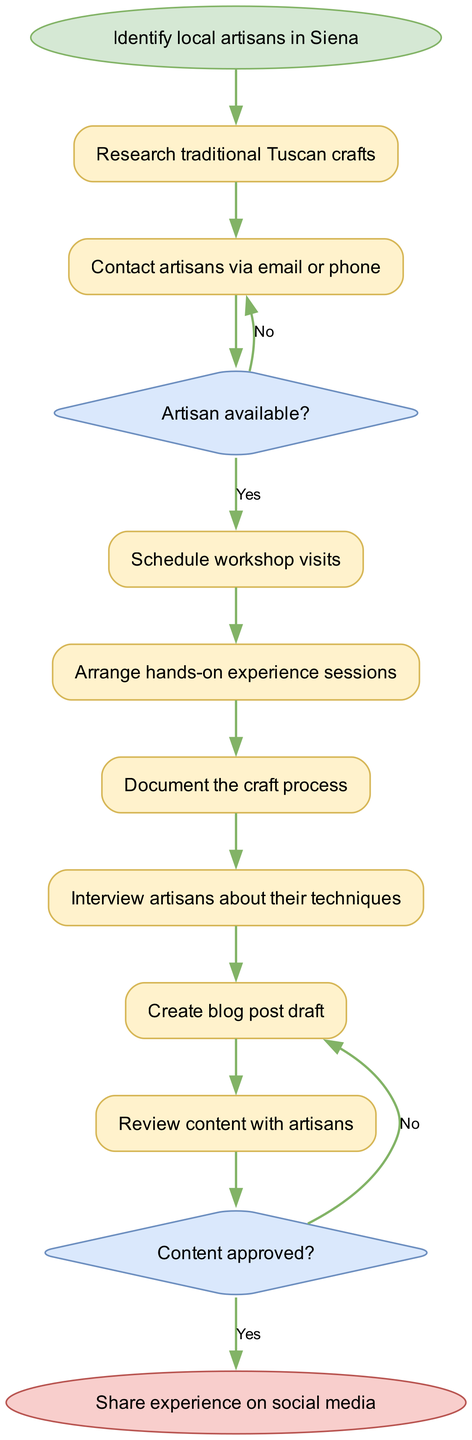What is the starting point of the flow? The starting point of the flow is indicated by the "start" node, which is "Identify local artisans in Siena". This node represents the initial action to take in the process.
Answer: Identify local artisans in Siena How many nodes are in the diagram? The diagram contains a total of 8 nodes, including the start and end nodes, as well as the 6 process nodes that detail the actions taken.
Answer: 8 What is the first process node after the start node? The first process node that follows the start node is "Research traditional Tuscan crafts". This node outlines the first step in the workflow.
Answer: Research traditional Tuscan crafts What is the outcome when an artisan is available? If the artisan is available, the process moves to the "Schedule workshop visits" node, as indicated in the decision that follows the artisan availability check.
Answer: Schedule workshop visits What happens if the content is not approved? If the content is not approved, it leads back to the "Revise content" node for further editing before possibly re-approving. This is indicated in the last decision of the chart.
Answer: Revise content What is the final step in the process? The final step, shown by the last node connected to the flow, is "Share experience on social media", which serves as the concluding action.
Answer: Share experience on social media How many decision nodes are in the diagram? The diagram includes 2 decision nodes that represent choices to be made during the process flow, specifically based on artisan availability and content approval.
Answer: 2 What process occurs immediately after documenting the craft process? The process that occurs immediately after documenting the craft process is "Interview artisans about their techniques", as indicated by the direct connection from the documentation step.
Answer: Interview artisans about their techniques What label is associated with the "Yes" path for artisan availability? The label associated with the "Yes" path in the artisan availability decision is "Schedule workshop visits", which directs the flow to the next step if at least one artisan is available.
Answer: Schedule workshop visits 